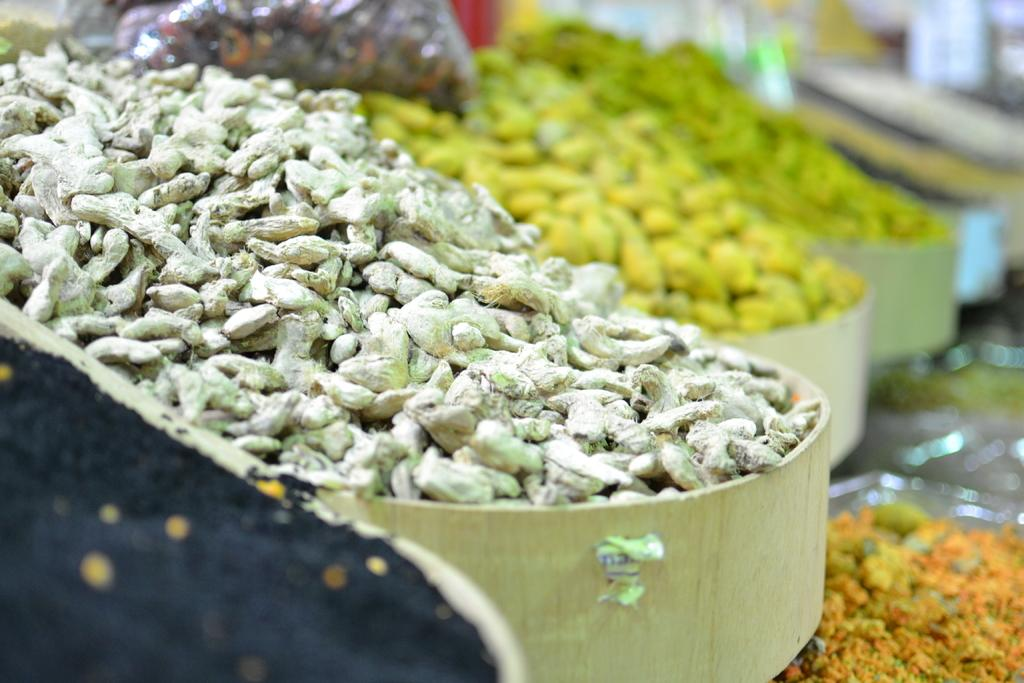What is present in the bowls in the image? There are spices in bowls in the image. Can you describe the background of the image? The background of the image is blurred. What type of brush is being used to write on the pickle in the image? There is no brush or pickle present in the image; it only features spices in bowls with a blurred background. 